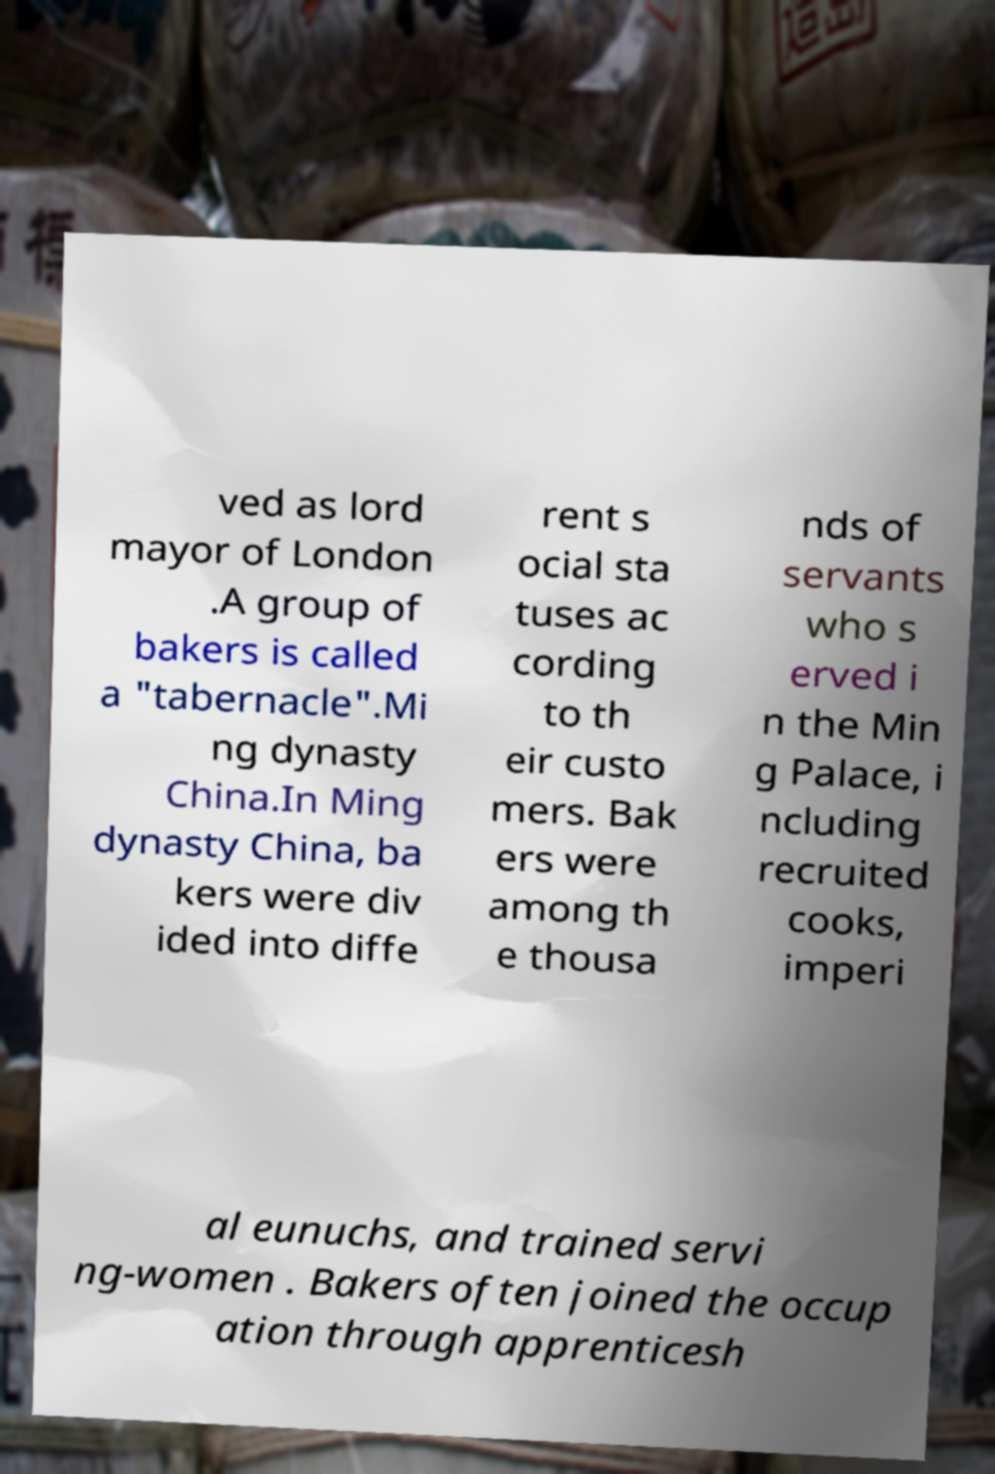Could you assist in decoding the text presented in this image and type it out clearly? ved as lord mayor of London .A group of bakers is called a "tabernacle".Mi ng dynasty China.In Ming dynasty China, ba kers were div ided into diffe rent s ocial sta tuses ac cording to th eir custo mers. Bak ers were among th e thousa nds of servants who s erved i n the Min g Palace, i ncluding recruited cooks, imperi al eunuchs, and trained servi ng-women . Bakers often joined the occup ation through apprenticesh 